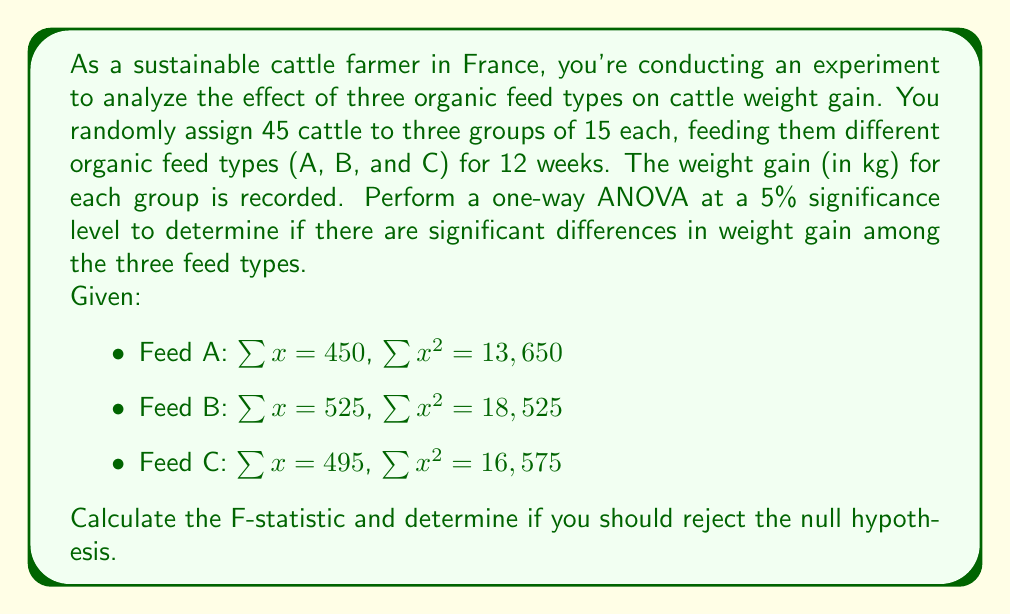Solve this math problem. Let's approach this step-by-step:

1) First, calculate the total sum of squares (SST):
   $$SST = \sum x^2 - \frac{(\sum x)^2}{N}$$
   $$SST = (13650 + 18525 + 16575) - \frac{(450 + 525 + 495)^2}{45}$$
   $$SST = 48750 - \frac{2160000}{45} = 48750 - 48000 = 750$$

2) Calculate the between-group sum of squares (SSB):
   $$SSB = \sum \frac{(\sum x_i)^2}{n_i} - \frac{(\sum x)^2}{N}$$
   $$SSB = \frac{450^2}{15} + \frac{525^2}{15} + \frac{495^2}{15} - \frac{1470^2}{45}$$
   $$SSB = 13500 + 18375 + 16335 - 48000 = 210$$

3) Calculate the within-group sum of squares (SSW):
   $$SSW = SST - SSB = 750 - 210 = 540$$

4) Degrees of freedom:
   - Between groups: $df_B = k - 1 = 3 - 1 = 2$
   - Within groups: $df_W = N - k = 45 - 3 = 42$
   - Total: $df_T = N - 1 = 45 - 1 = 44$

5) Calculate mean squares:
   $$MSB = \frac{SSB}{df_B} = \frac{210}{2} = 105$$
   $$MSW = \frac{SSW}{df_W} = \frac{540}{42} = 12.86$$

6) Calculate the F-statistic:
   $$F = \frac{MSB}{MSW} = \frac{105}{12.86} = 8.17$$

7) The critical F-value for $\alpha = 0.05$, $df_B = 2$, and $df_W = 42$ is approximately 3.22 (from F-distribution table).

Since the calculated F-statistic (8.17) is greater than the critical F-value (3.22), we reject the null hypothesis.
Answer: F-statistic = 8.17

Reject the null hypothesis. There is significant evidence at the 5% level to conclude that there are differences in weight gain among the three organic feed types. 